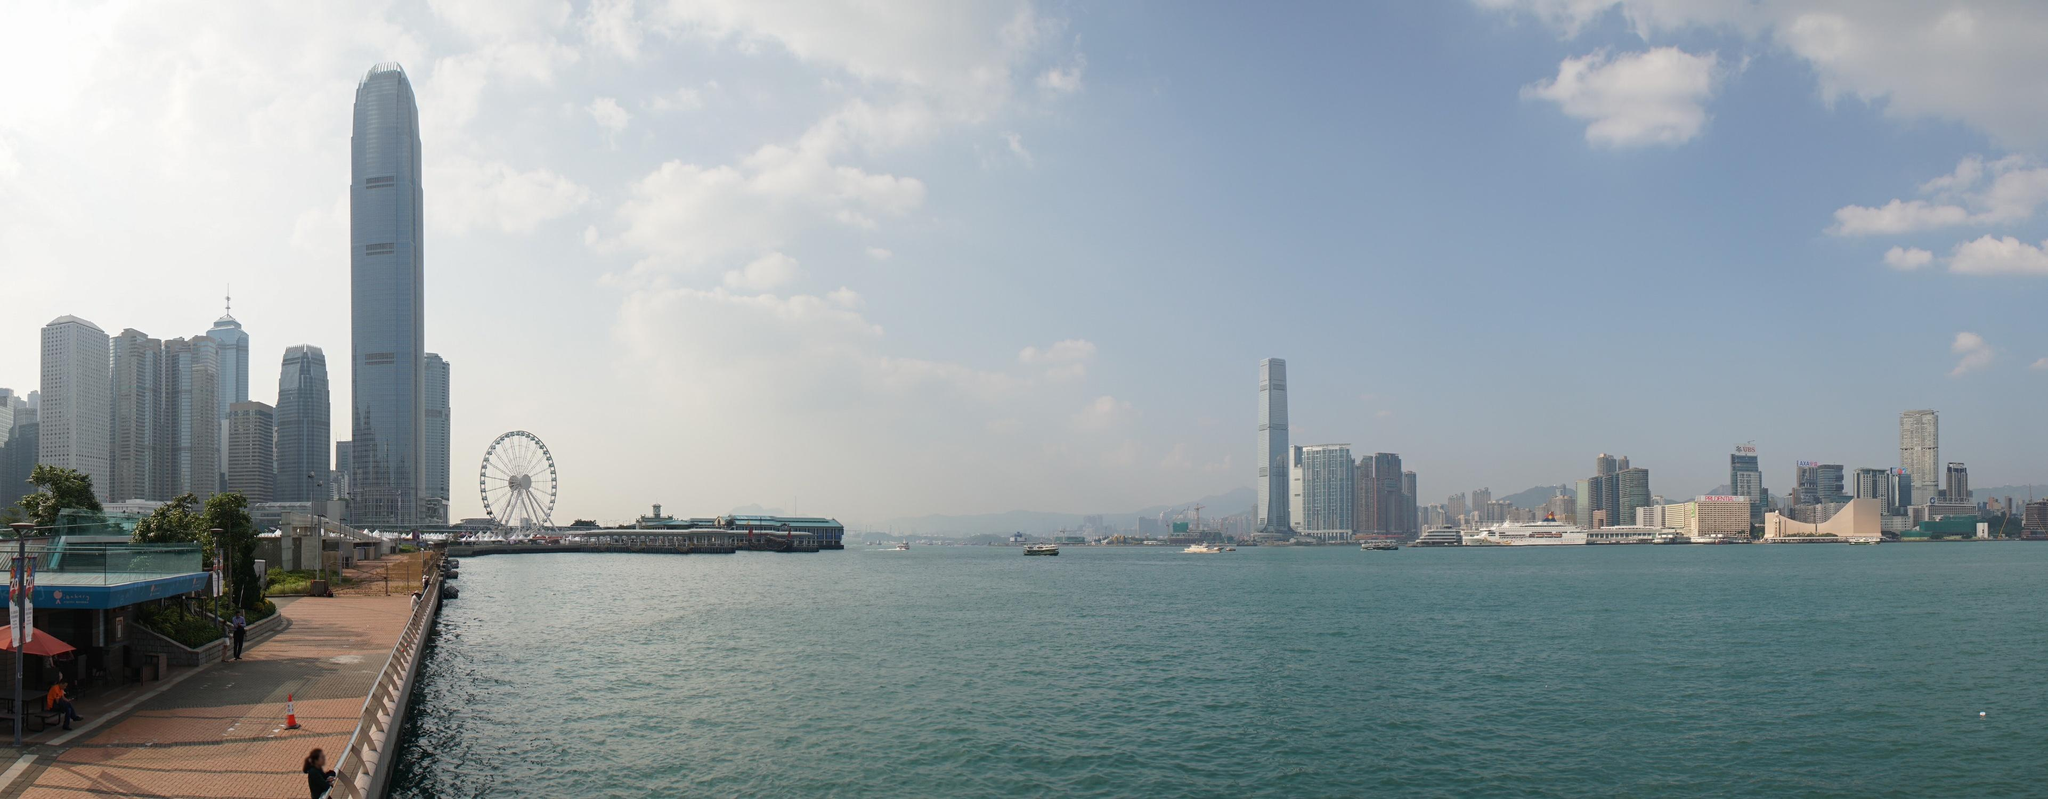How might this scene change at night? At night, this scene would transform into a mesmerizing array of lights. The skyscrapers would likely be illuminated, their lights reflecting on the calm waters of the harbor. The ferris wheel could be glowing with colorful lights, adding a festive touch to the night skyline. The waterfront promenade could be softly lit by street lamps, creating a cozy and inviting atmosphere for evening strollers. The clear night sky might be dotted with stars, further enhancing the beauty of the night scene. Nightlife would bloom, with people perhaps enjoying night markets, outdoor dining, or simply the serene ambiance of the waterfront. That sounds beautiful. What kind of events do you think could be held in this location? This scenic waterfront location would be perfect for a variety of events. Evening concerts with the skyline as a backdrop would be incredibly captivating, offering a cool urban vibe. Food festivals showcasing diverse cuisines could draw food enthusiasts, while cultural festivals could bring a blend of traditional and modern performances, celebrating the city's rich heritage. Seasonal events like a New Year's Eve fireworks show or a holiday light display could create unforgettable experiences for attendees. Art installations and open-air exhibitions could also take advantage of the expansive space, providing a platform for local artists to showcase their works. 